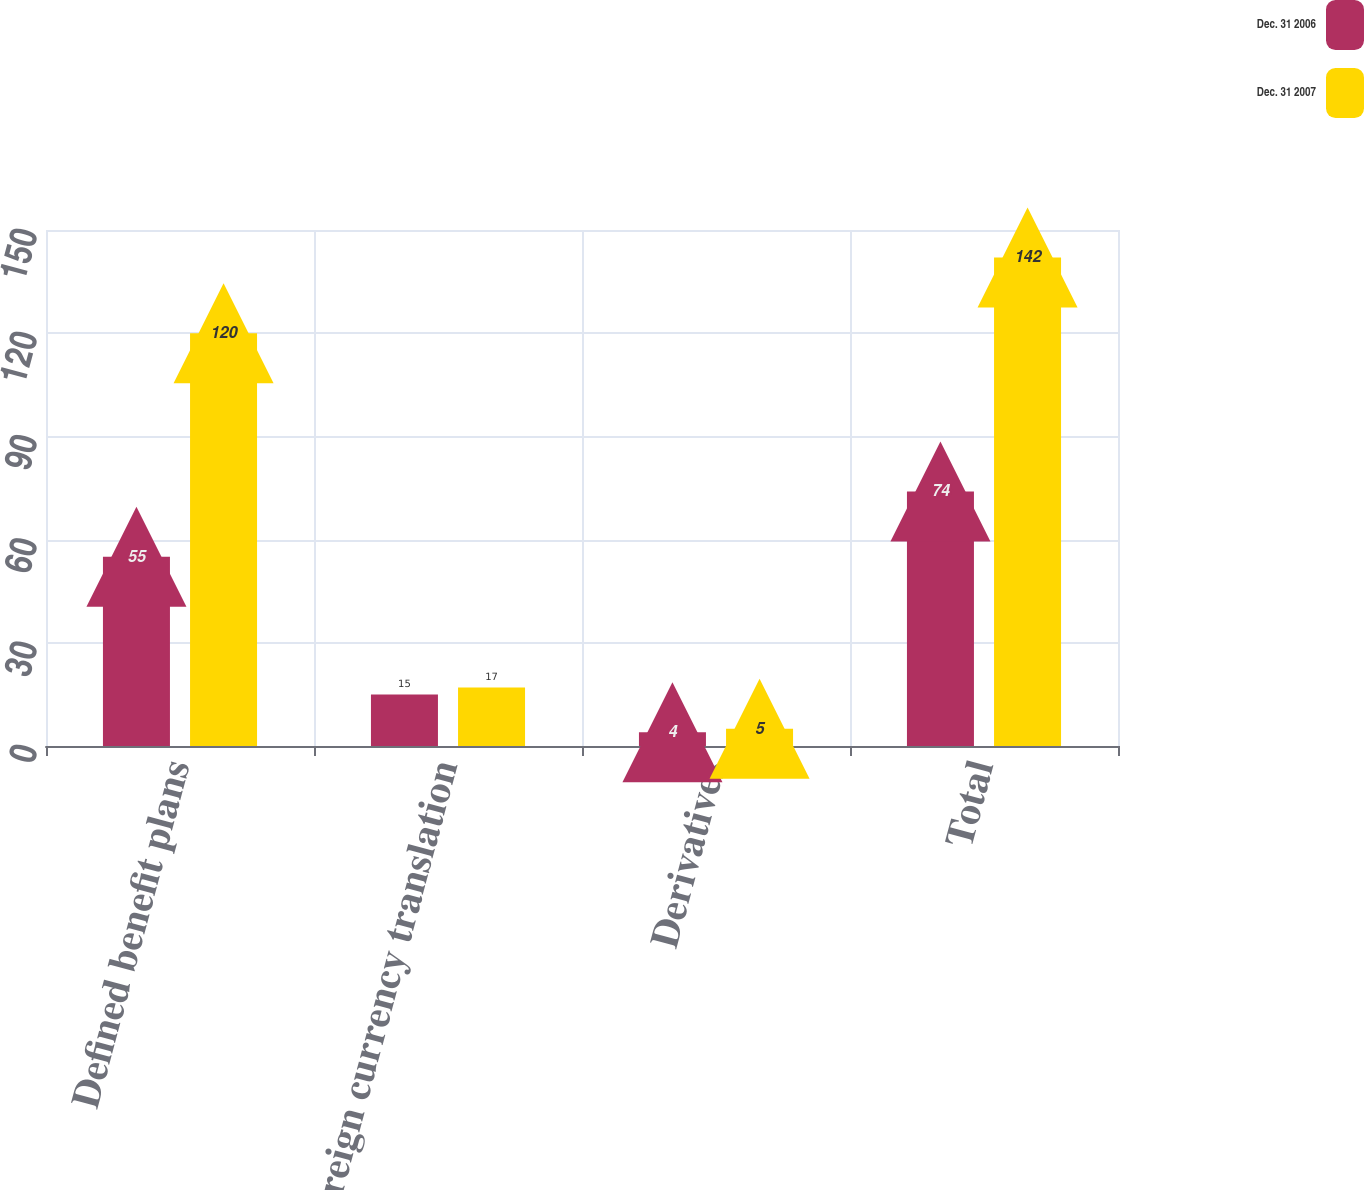<chart> <loc_0><loc_0><loc_500><loc_500><stacked_bar_chart><ecel><fcel>Defined benefit plans<fcel>Foreign currency translation<fcel>Derivatives<fcel>Total<nl><fcel>Dec. 31 2006<fcel>55<fcel>15<fcel>4<fcel>74<nl><fcel>Dec. 31 2007<fcel>120<fcel>17<fcel>5<fcel>142<nl></chart> 